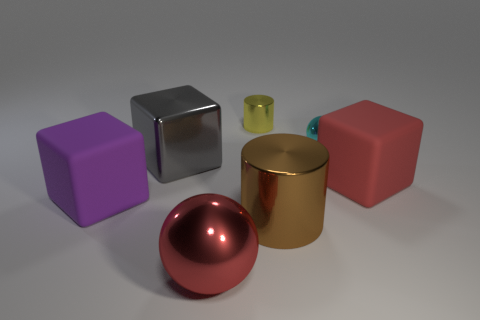Does the brown shiny cylinder have the same size as the metal cylinder that is behind the big gray metal object?
Your answer should be very brief. No. The ball in front of the block that is left of the gray block is what color?
Your response must be concise. Red. What number of other objects are the same color as the large metal cylinder?
Your answer should be very brief. 0. What is the size of the yellow cylinder?
Offer a very short reply. Small. Is the number of purple cubes that are left of the purple matte thing greater than the number of tiny cylinders behind the tiny cyan object?
Keep it short and to the point. No. There is a shiny cylinder on the left side of the large metallic cylinder; how many cyan spheres are to the right of it?
Keep it short and to the point. 1. There is a red object that is behind the purple thing; is it the same shape as the large purple matte thing?
Provide a succinct answer. Yes. What material is the big red object that is the same shape as the big purple matte object?
Give a very brief answer. Rubber. How many other brown rubber objects are the same size as the brown object?
Make the answer very short. 0. There is a big thing that is both on the right side of the big gray object and behind the brown object; what is its color?
Your response must be concise. Red. 